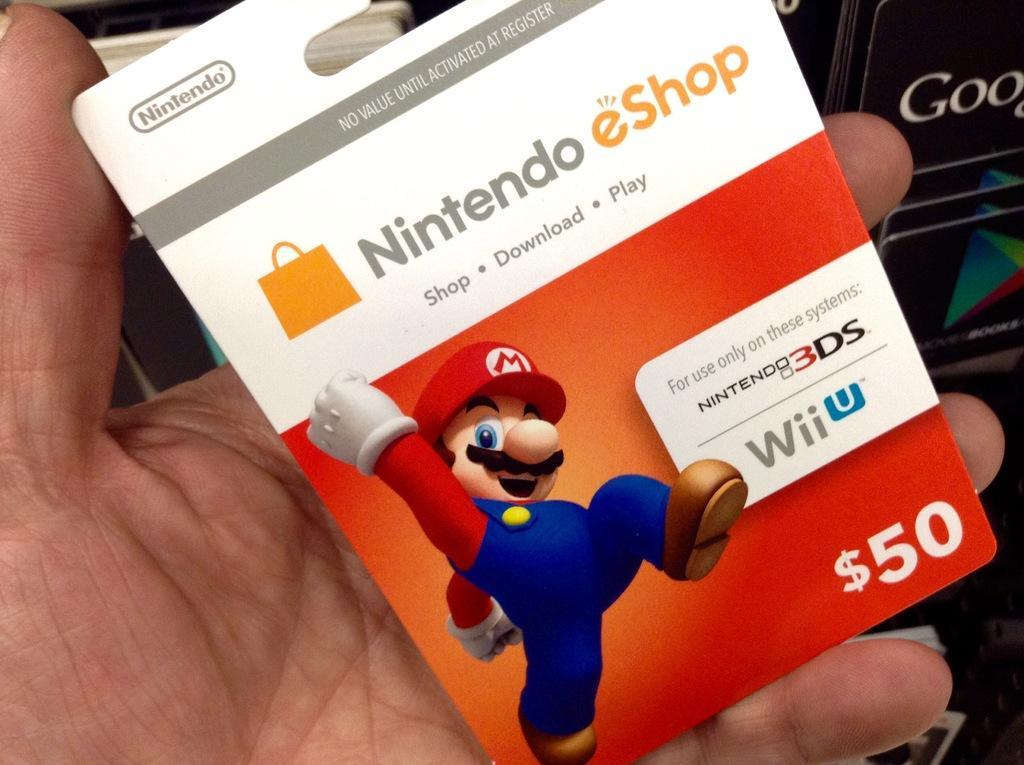How would you summarize this image in a sentence or two? In this image we can see a human hand holding a card in which we can see an image of the cartoon and some text written on it. 